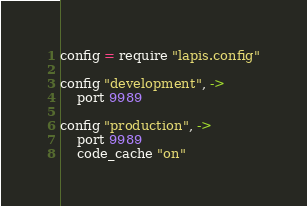<code> <loc_0><loc_0><loc_500><loc_500><_MoonScript_>config = require "lapis.config"

config "development", ->
	port 9989

config "production", ->
	port 9989
	code_cache "on"</code> 